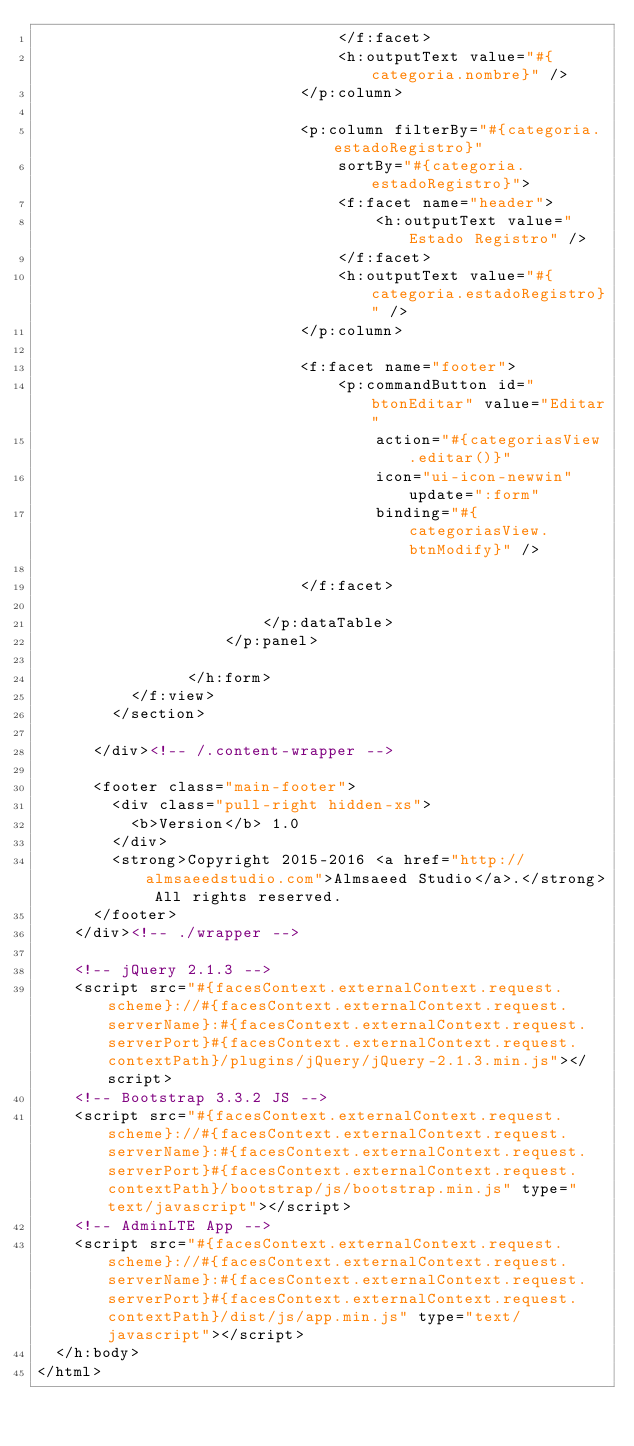<code> <loc_0><loc_0><loc_500><loc_500><_HTML_>								</f:facet>
								<h:outputText value="#{categoria.nombre}" />
							</p:column>

							<p:column filterBy="#{categoria.estadoRegistro}"
								sortBy="#{categoria.estadoRegistro}">
								<f:facet name="header">
									<h:outputText value="Estado Registro" />
								</f:facet>
								<h:outputText value="#{categoria.estadoRegistro}" />
							</p:column>

							<f:facet name="footer">
								<p:commandButton id="btonEditar" value="Editar"
									action="#{categoriasView.editar()}" 
									icon="ui-icon-newwin" update=":form"
									binding="#{categoriasView.btnModify}" />

							</f:facet>

						</p:dataTable>
					</p:panel>
					
				</h:form>
		  </f:view>
        </section>

      </div><!-- /.content-wrapper -->

      <footer class="main-footer">
        <div class="pull-right hidden-xs">
          <b>Version</b> 1.0
        </div>
        <strong>Copyright 2015-2016 <a href="http://almsaeedstudio.com">Almsaeed Studio</a>.</strong> All rights reserved.
      </footer>
    </div><!-- ./wrapper -->

    <!-- jQuery 2.1.3 -->
    <script src="#{facesContext.externalContext.request.scheme}://#{facesContext.externalContext.request.serverName}:#{facesContext.externalContext.request.serverPort}#{facesContext.externalContext.request.contextPath}/plugins/jQuery/jQuery-2.1.3.min.js"></script>
    <!-- Bootstrap 3.3.2 JS -->
    <script src="#{facesContext.externalContext.request.scheme}://#{facesContext.externalContext.request.serverName}:#{facesContext.externalContext.request.serverPort}#{facesContext.externalContext.request.contextPath}/bootstrap/js/bootstrap.min.js" type="text/javascript"></script>
    <!-- AdminLTE App -->
    <script src="#{facesContext.externalContext.request.scheme}://#{facesContext.externalContext.request.serverName}:#{facesContext.externalContext.request.serverPort}#{facesContext.externalContext.request.contextPath}/dist/js/app.min.js" type="text/javascript"></script>
  </h:body>
</html>
</code> 